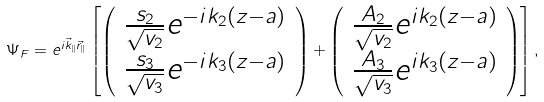<formula> <loc_0><loc_0><loc_500><loc_500>\Psi _ { F } = e ^ { i \vec { k } _ { | | } \vec { r } _ { | | } } \left [ \left ( \begin{array} { c } \frac { s _ { 2 } } { \sqrt { v _ { 2 } } } e ^ { - i k _ { 2 } ( z - a ) } \\ \frac { s _ { 3 } } { \sqrt { v _ { 3 } } } e ^ { - i k _ { 3 } ( z - a ) } \end{array} \right ) + \left ( \begin{array} { c } \frac { A _ { 2 } } { \sqrt { v _ { 2 } } } e ^ { i k _ { 2 } ( z - a ) } \\ \frac { A _ { 3 } } { \sqrt { v _ { 3 } } } e ^ { i k _ { 3 } ( z - a ) } \end{array} \right ) \right ] ,</formula> 